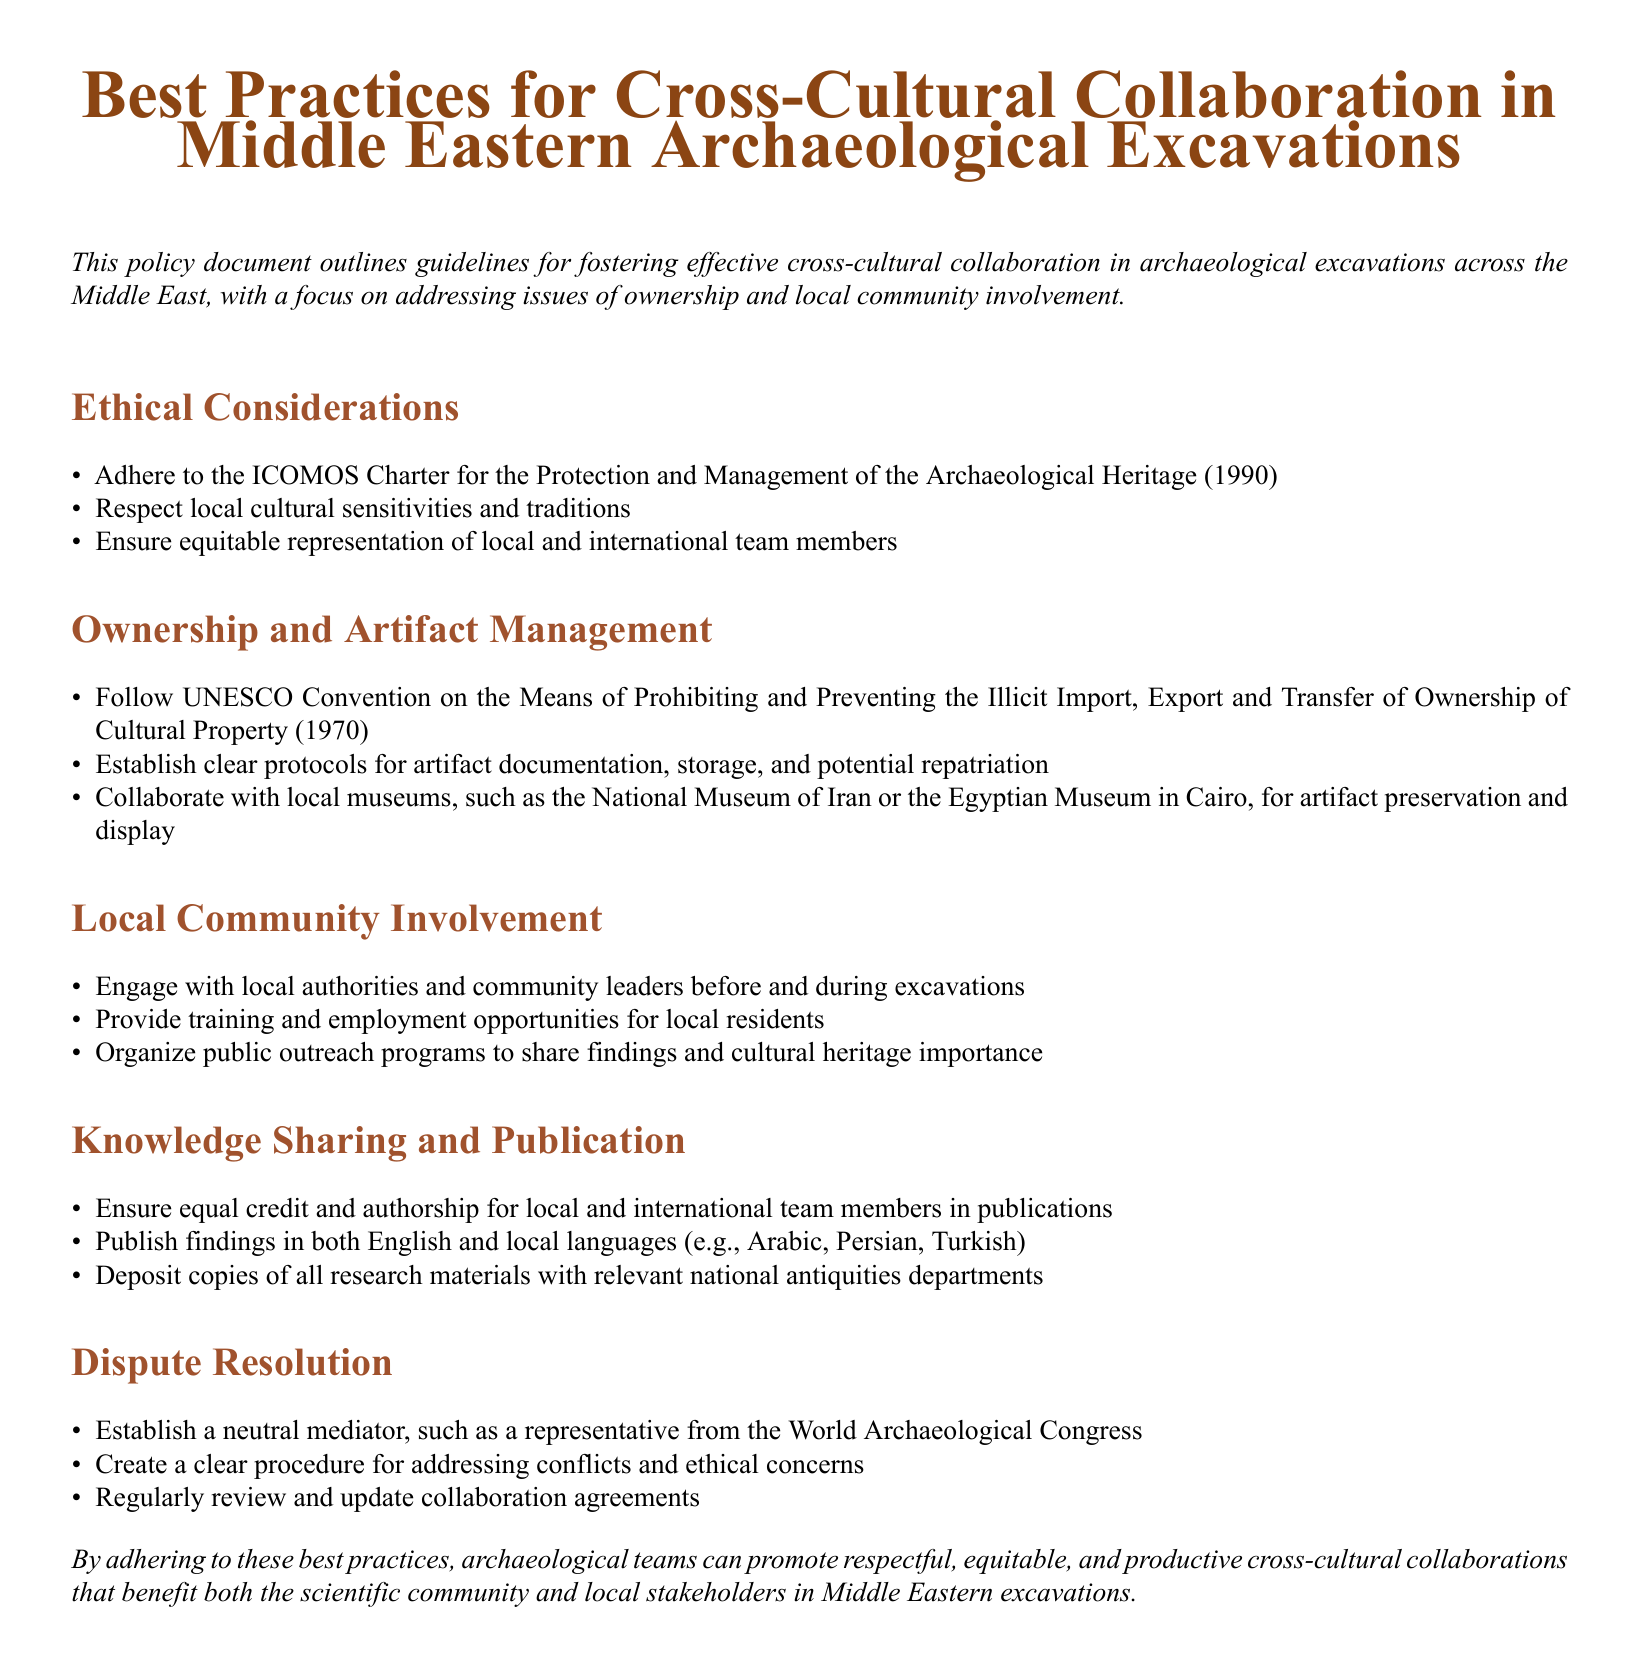What is the title of the document? The title is prominently displayed at the top of the document, highlighting its focus on collaboration in archaeological excavations.
Answer: Best Practices for Cross-Cultural Collaboration in Middle Eastern Archaeological Excavations What year was the ICOMOS Charter established? The document references the ICOMOS Charter for the Protection and Management of the Archaeological Heritage, which was established in 1990.
Answer: 1990 What convention does the document refer to regarding cultural property? The document mentions a specific convention that addresses the illicit import, export, and ownership of cultural property.
Answer: UNESCO Convention Who should be engaged with before and during excavations? The document specifies the key stakeholders that archaeological teams should engage with to ensure collaboration.
Answer: Local authorities and community leaders What should be done with research materials according to the document? The document states a requirement for the handling of research materials to ensure their availability and accountability.
Answer: Deposit copies of all research materials with relevant national antiquities departments Which museums are mentioned for artifact preservation? The document lists specific museums that can be involved in artifact preservation efforts, ensuring local collaboration.
Answer: National Museum of Iran or the Egyptian Museum in Cairo What is encouraged for local residents in excavations? The document emphasizes the importance of providing opportunities to local residents during archaeological excavations.
Answer: Training and employment opportunities Who should mediate disputes according to the document? The document identifies a specific role or organization that should serve as a neutral mediator in resolving conflicts.
Answer: Representative from the World Archaeological Congress 